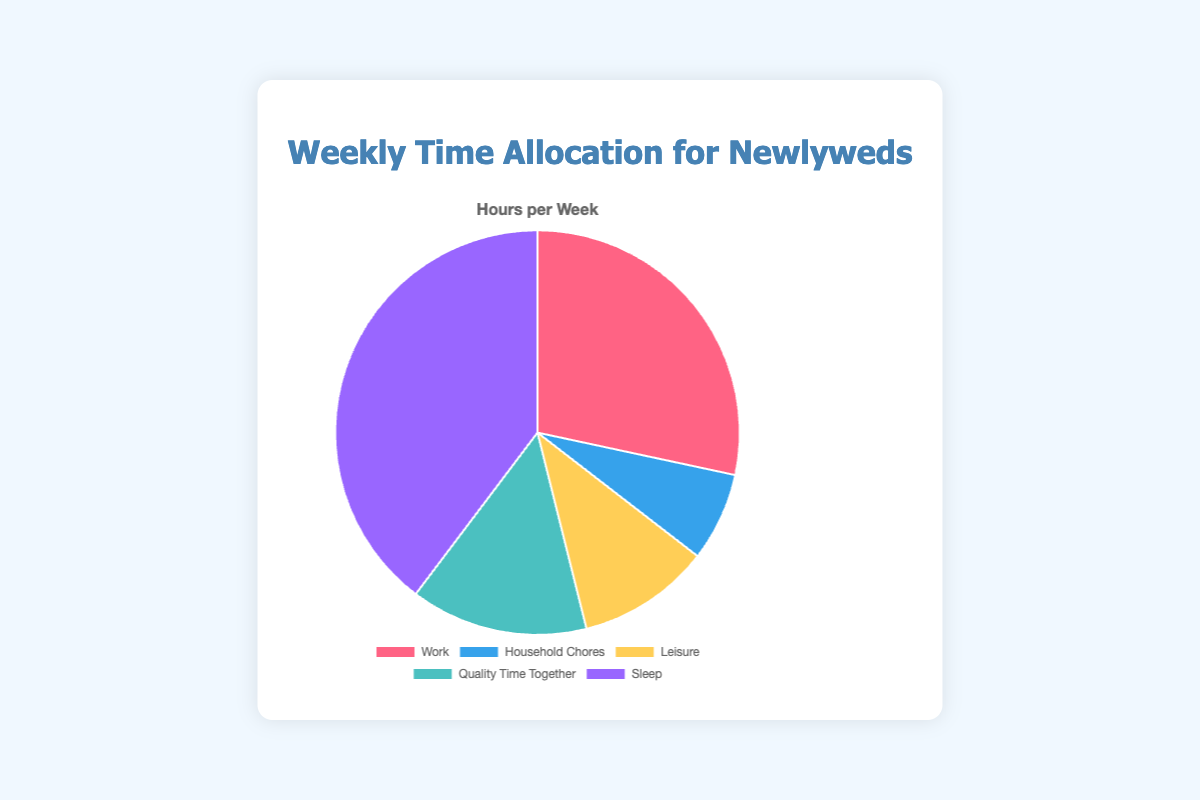What is the activity with the highest time allocation? By looking at the pie chart, we can see that the largest segment represents Sleep. Sleeping takes up 56 hours per week, which is higher than any other activity.
Answer: Sleep How many more hours per week are spent on Sleep compared to Work? Sleep is allocated 56 hours per week, while Work is allocated 40 hours per week. The difference is 56 - 40 = 16 hours.
Answer: 16 What is the combined time spent on Leisure and Quality Time Together? Leisure takes up 15 hours per week, and Quality Time Together takes up 20 hours per week. The combined time is 15 + 20 = 35 hours.
Answer: 35 Which color represents Household Chores on the pie chart? By referring to the visual representation in the pie chart, we see that Household Chores are represented by the blue segment.
Answer: Blue How many hours in total are dedicated to activities other than Sleep? The hours spent on other activities (Work, Household Chores, Leisure, Quality Time Together) are 40 + 10 + 15 + 20 = 85 hours.
Answer: 85 Is more time spent on Work or Leisure? Referring to the pie chart, Work takes up 40 hours, while Leisure takes up 15 hours per week. Thus, more time is spent on Work.
Answer: Work What is the least time-consuming activity in the week? According to the pie chart, the smallest segment represents Household Chores, which takes up 10 hours per week.
Answer: Household Chores How does the time for Quality Time Together compare to the time for Household Chores and Leisure combined? Quality Time Together takes up 20 hours. Household Chores and Leisure combined take up 10 + 15 = 25 hours. Therefore, 25 is greater than 20.
Answer: Less What proportion of the week is spent sleeping? There are 168 hours in a week (24 hours/day * 7 days/week). Sleep takes up 56 hours, so the proportion is 56 / 168 = 1/3 or approximately 33.33%.
Answer: Approximately 33.33% 